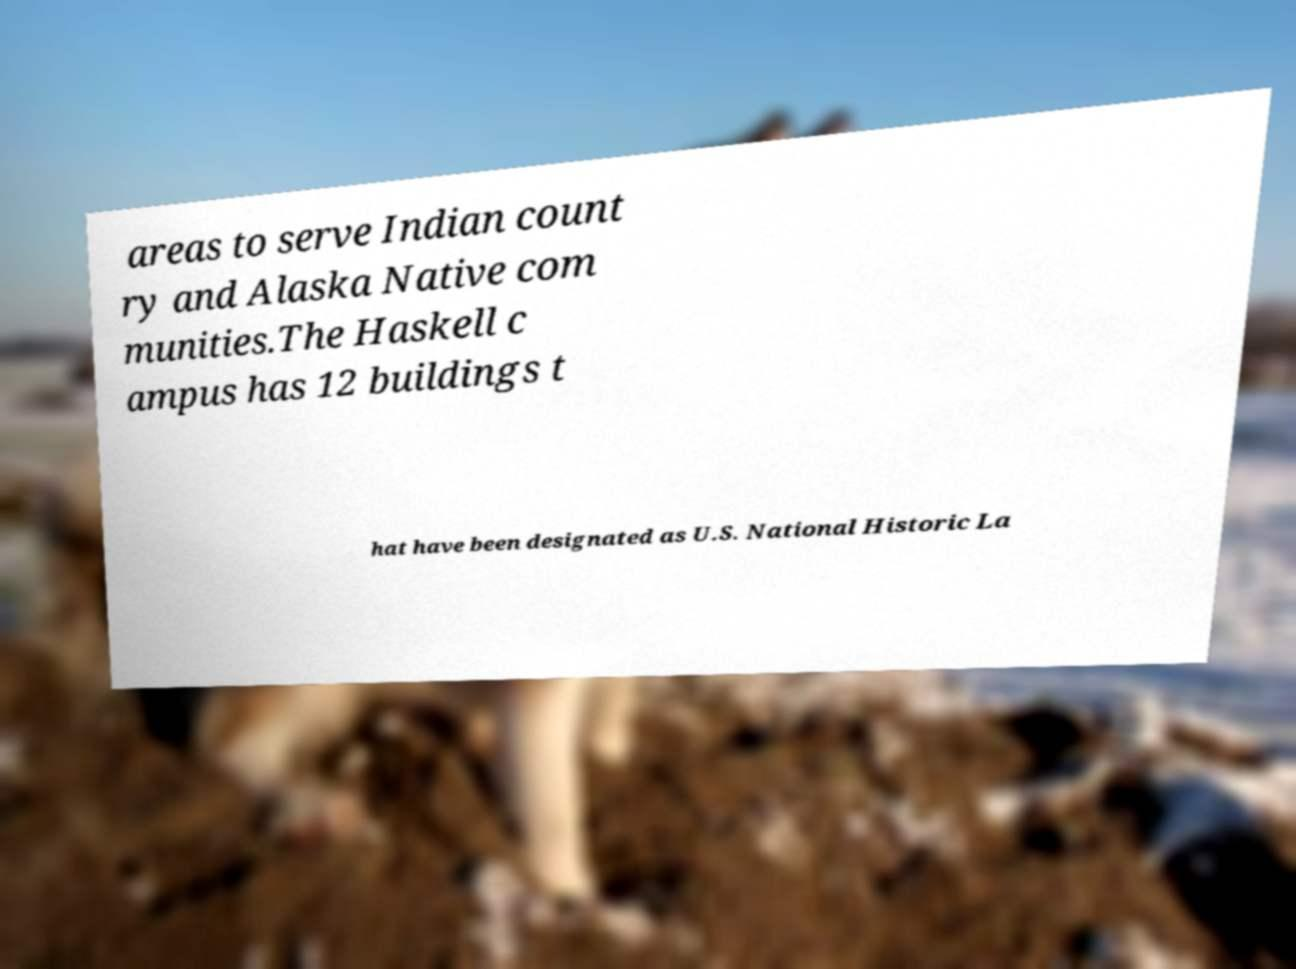Could you assist in decoding the text presented in this image and type it out clearly? areas to serve Indian count ry and Alaska Native com munities.The Haskell c ampus has 12 buildings t hat have been designated as U.S. National Historic La 